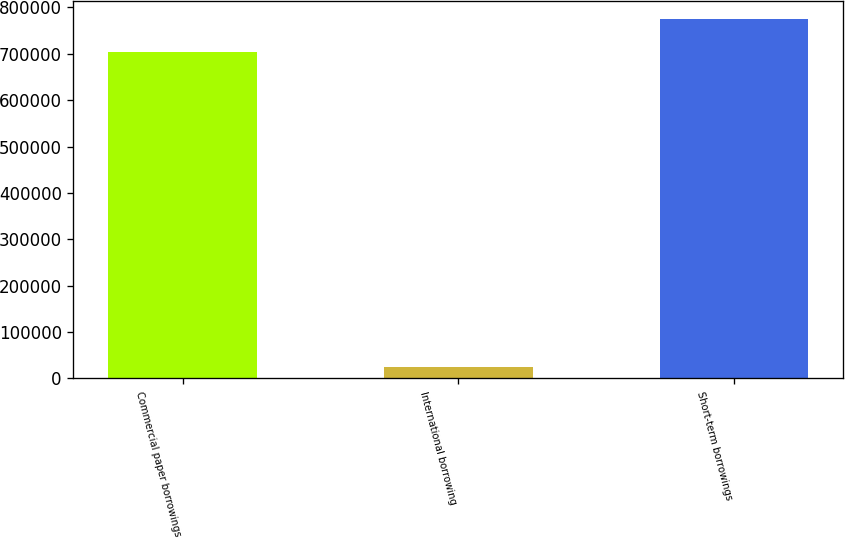Convert chart to OTSL. <chart><loc_0><loc_0><loc_500><loc_500><bar_chart><fcel>Commercial paper borrowings<fcel>International borrowing<fcel>Short-term borrowings<nl><fcel>705000<fcel>24384<fcel>775500<nl></chart> 